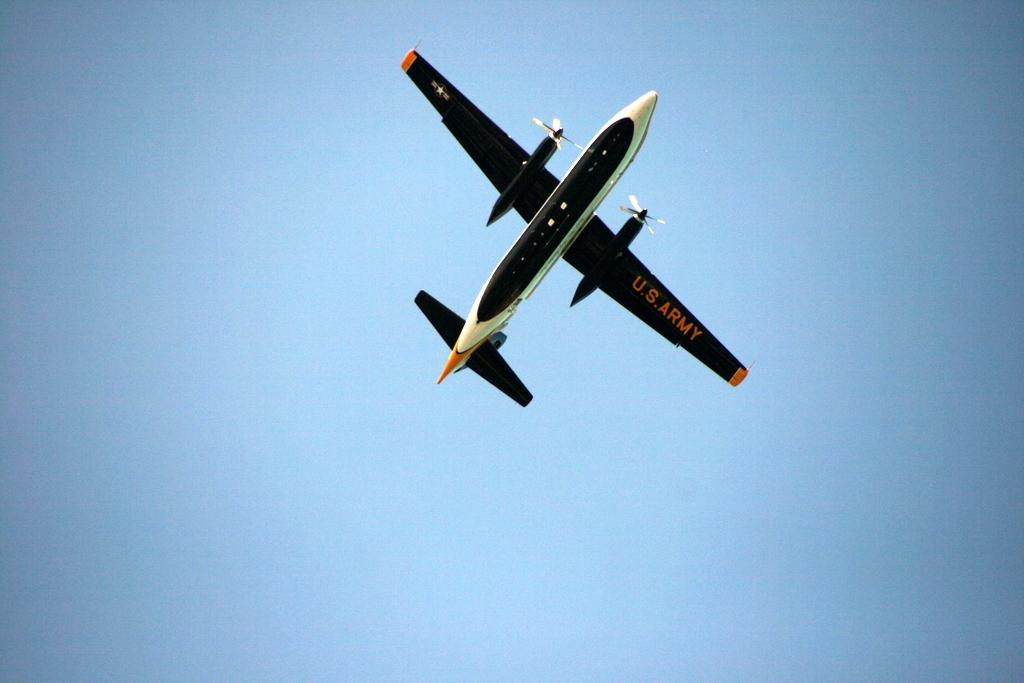What is the main subject of the image? The main subject of the image is an airplane. Where is the airplane located in the image? The airplane is in the sky. What type of bottle can be seen in the image? There is no bottle present in the image. 